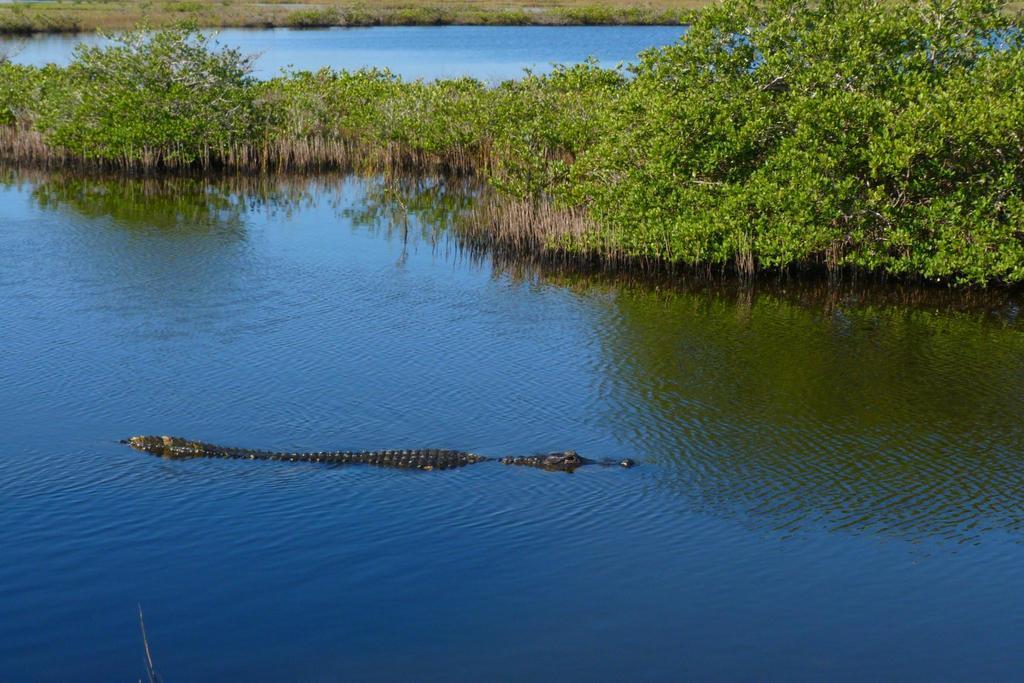Please provide a concise description of this image. In this picture we can see a crocodile in the water and trees. In the background of the image we can see plants and grass. 